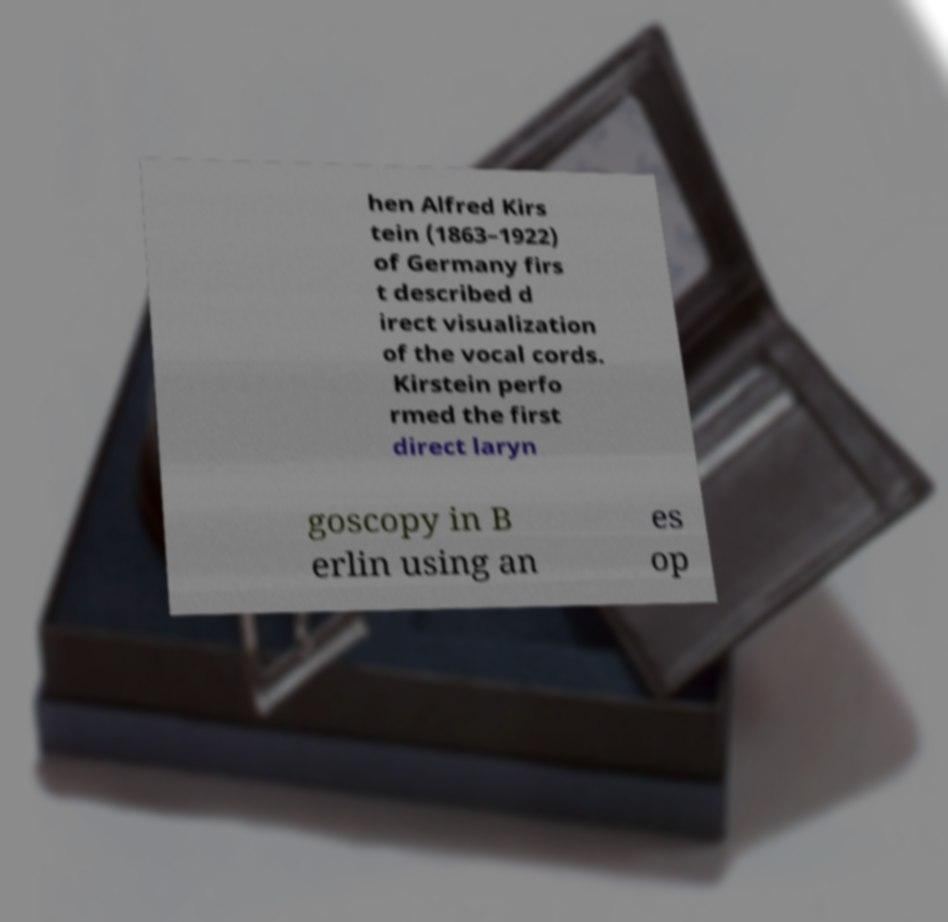I need the written content from this picture converted into text. Can you do that? hen Alfred Kirs tein (1863–1922) of Germany firs t described d irect visualization of the vocal cords. Kirstein perfo rmed the first direct laryn goscopy in B erlin using an es op 